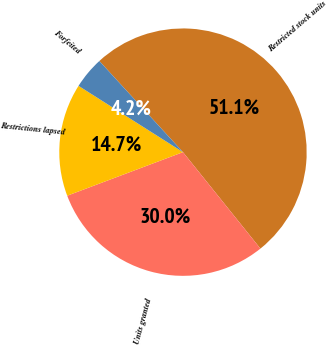Convert chart to OTSL. <chart><loc_0><loc_0><loc_500><loc_500><pie_chart><fcel>Restricted stock units<fcel>Units granted<fcel>Restrictions lapsed<fcel>Forfeited<nl><fcel>51.05%<fcel>30.04%<fcel>14.73%<fcel>4.18%<nl></chart> 